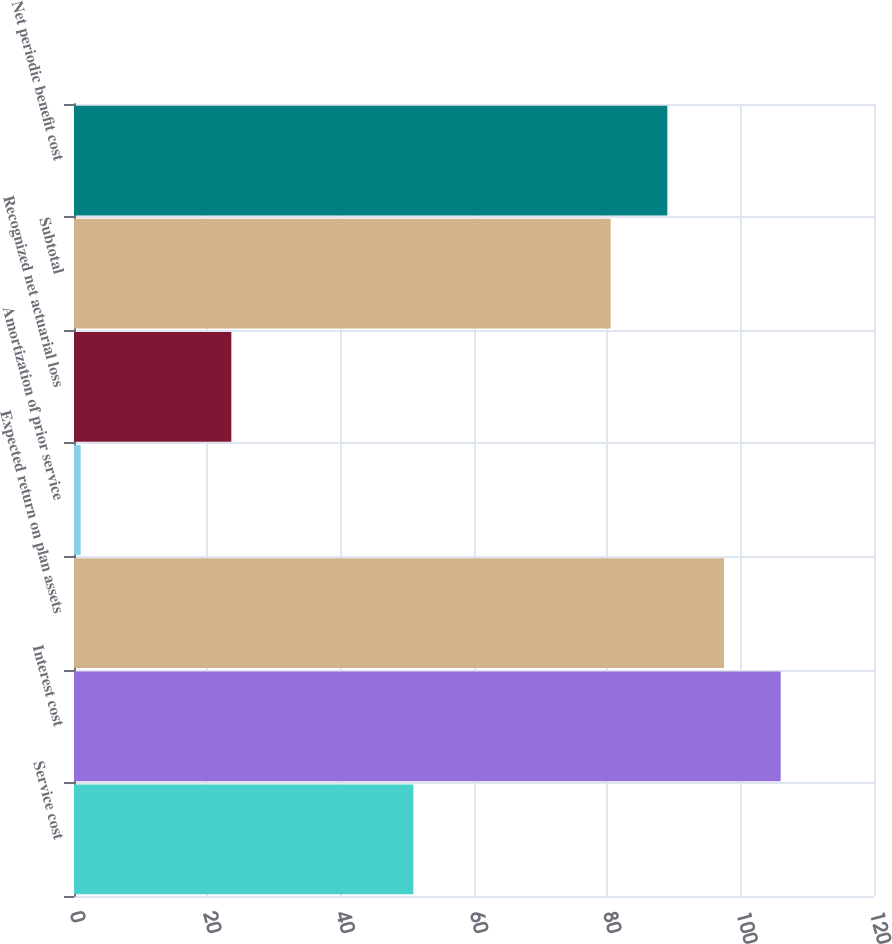Convert chart. <chart><loc_0><loc_0><loc_500><loc_500><bar_chart><fcel>Service cost<fcel>Interest cost<fcel>Expected return on plan assets<fcel>Amortization of prior service<fcel>Recognized net actuarial loss<fcel>Subtotal<fcel>Net periodic benefit cost<nl><fcel>50.9<fcel>106<fcel>97.5<fcel>1<fcel>23.6<fcel>80.5<fcel>89<nl></chart> 